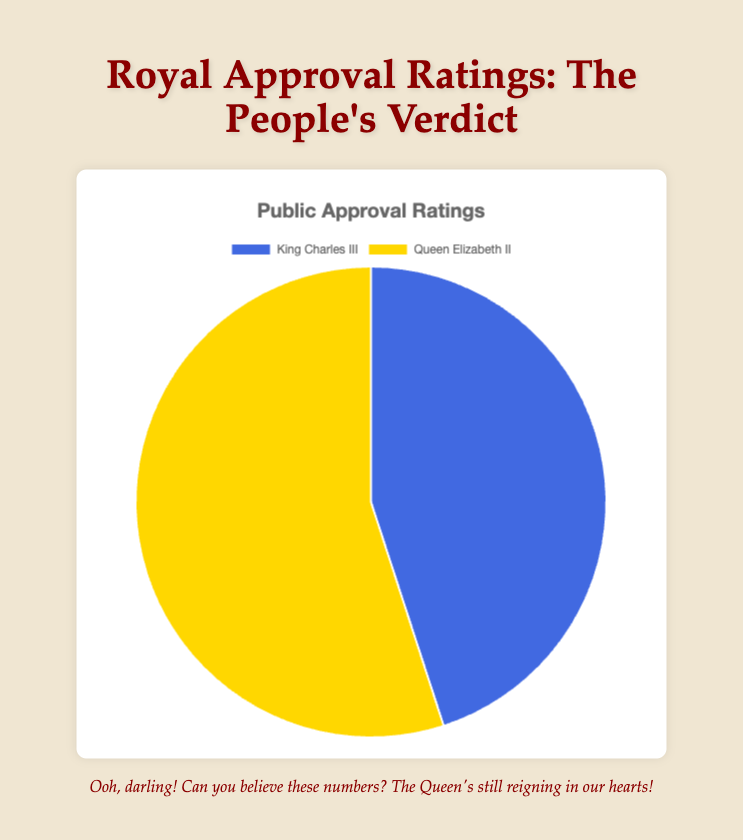Which royal figure has a higher public approval rating? The pie chart shows approval ratings for King Charles III and Queen Elizabeth II. The segment for Queen Elizabeth II is larger, indicating she has a higher approval rating.
Answer: Queen Elizabeth II What is the difference in approval ratings between King Charles III and Queen Elizabeth II? Queen Elizabeth II has an approval rating of 55%, while King Charles III has 45%. Subtract 45 from 55 to find the difference.
Answer: 10% What is the total approval rating represented in the pie chart? The pie chart represents the entire approval ratings as 100%. Adding the ratings for King Charles III (45%) and Queen Elizabeth II (55%) confirms this.
Answer: 100% If the approval ratings were to flip, what percentage would King Charles III have? Currently, Queen Elizabeth II has 55% and King Charles III has 45%. If they flipped, the ratings would be reversed.
Answer: 55% How much more popular, percentage-wise, is Queen Elizabeth II compared to King Charles III? The approval rating for Queen Elizabeth II is 55%, and for King Charles III is 45%. The difference is their popularity gap. 55 - 45 equals 10.
Answer: 10% Which color segment represents Queen Elizabeth II's approval rating? The pie chart uses colors to differentiate the segments. The segment for Queen Elizabeth II is colored gold.
Answer: Gold What part of the pie chart represents King Charles III? The pie chart shows two segments. The segment colored royal blue represents King Charles III's approval rating of 45%.
Answer: Royal Blue If you combined the approval ratings of both royals, what fraction of the total would represent Queen Elizabeth II's rating? Combining both ratings is practically the whole (1 or 100%), and Queen Elizabeth II's approval rating is 55% of it. So, it represents 55 out of 100, which is 55%.
Answer: 55% How likely is it that a randomly selected approval falls under Queen Elizabeth II's favor? With Queen Elizabeth II having 55% of the approval, a randomly selected approval is 55% likely to be in her favor as shown by her larger segment on the pie chart.
Answer: 55% 